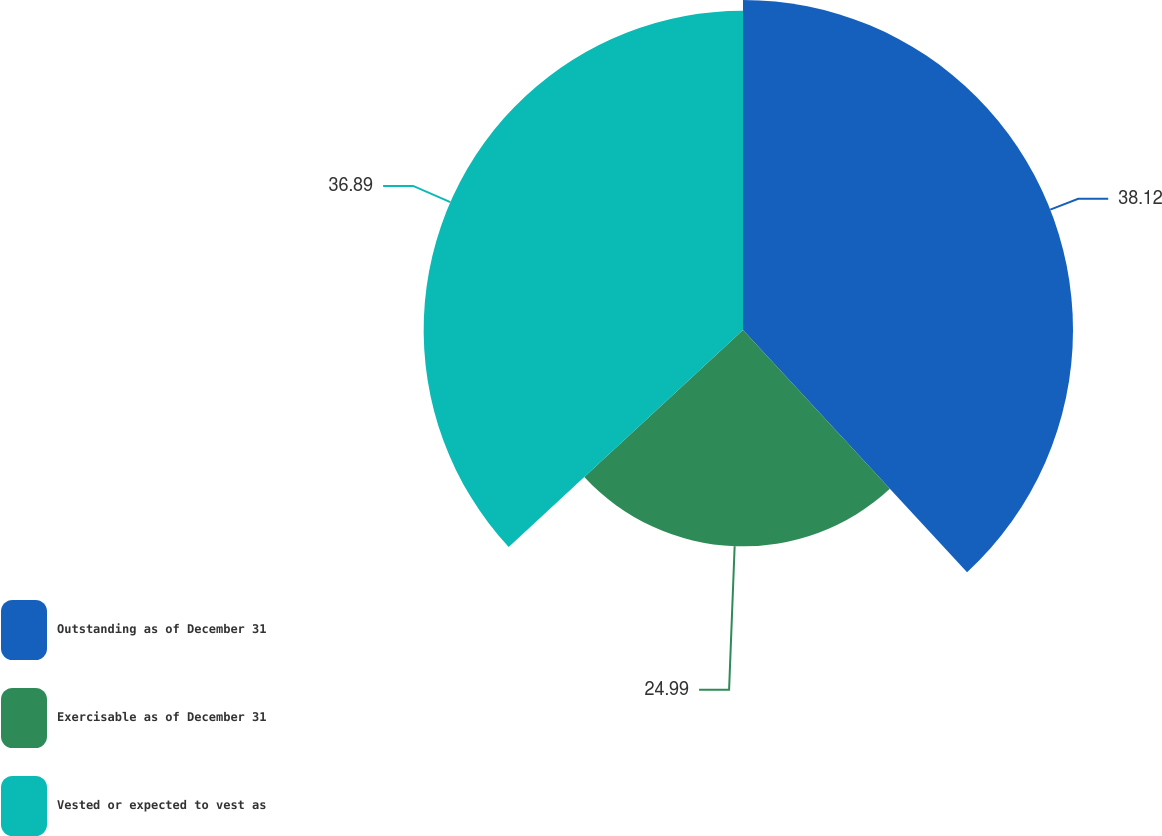<chart> <loc_0><loc_0><loc_500><loc_500><pie_chart><fcel>Outstanding as of December 31<fcel>Exercisable as of December 31<fcel>Vested or expected to vest as<nl><fcel>38.12%<fcel>24.99%<fcel>36.89%<nl></chart> 